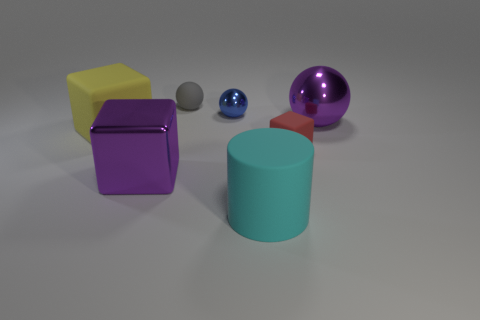Add 1 big green things. How many objects exist? 8 Subtract all red rubber blocks. How many blocks are left? 2 Subtract all purple blocks. How many blocks are left? 2 Subtract all cylinders. How many objects are left? 6 Add 7 shiny spheres. How many shiny spheres are left? 9 Add 5 blue metal spheres. How many blue metal spheres exist? 6 Subtract 1 blue spheres. How many objects are left? 6 Subtract all purple blocks. Subtract all purple cylinders. How many blocks are left? 2 Subtract all yellow blocks. Subtract all small cubes. How many objects are left? 5 